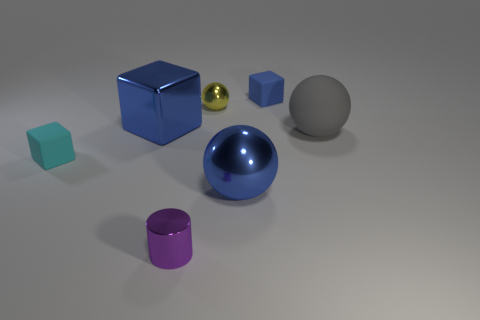There is a rubber object that is to the right of the small purple object and to the left of the gray rubber object; what size is it?
Ensure brevity in your answer.  Small. What is the material of the blue object that is the same shape as the yellow metallic thing?
Your response must be concise. Metal. There is a small block that is behind the matte cube that is left of the yellow sphere; what is it made of?
Offer a very short reply. Rubber. There is a cyan thing; is its shape the same as the big metallic thing left of the yellow shiny sphere?
Your answer should be very brief. Yes. What number of metal things are either big blue blocks or big things?
Your answer should be compact. 2. There is a rubber thing that is behind the large blue object that is on the left side of the small metallic cylinder that is in front of the small yellow object; what color is it?
Provide a short and direct response. Blue. How many other things are there of the same material as the tiny blue block?
Ensure brevity in your answer.  2. Is the shape of the tiny metal object that is in front of the yellow sphere the same as  the small yellow shiny object?
Provide a short and direct response. No. How many large things are brown metallic blocks or blue rubber cubes?
Provide a succinct answer. 0. Is the number of metallic cylinders on the right side of the cylinder the same as the number of small cyan cubes behind the cyan rubber block?
Offer a terse response. Yes. 